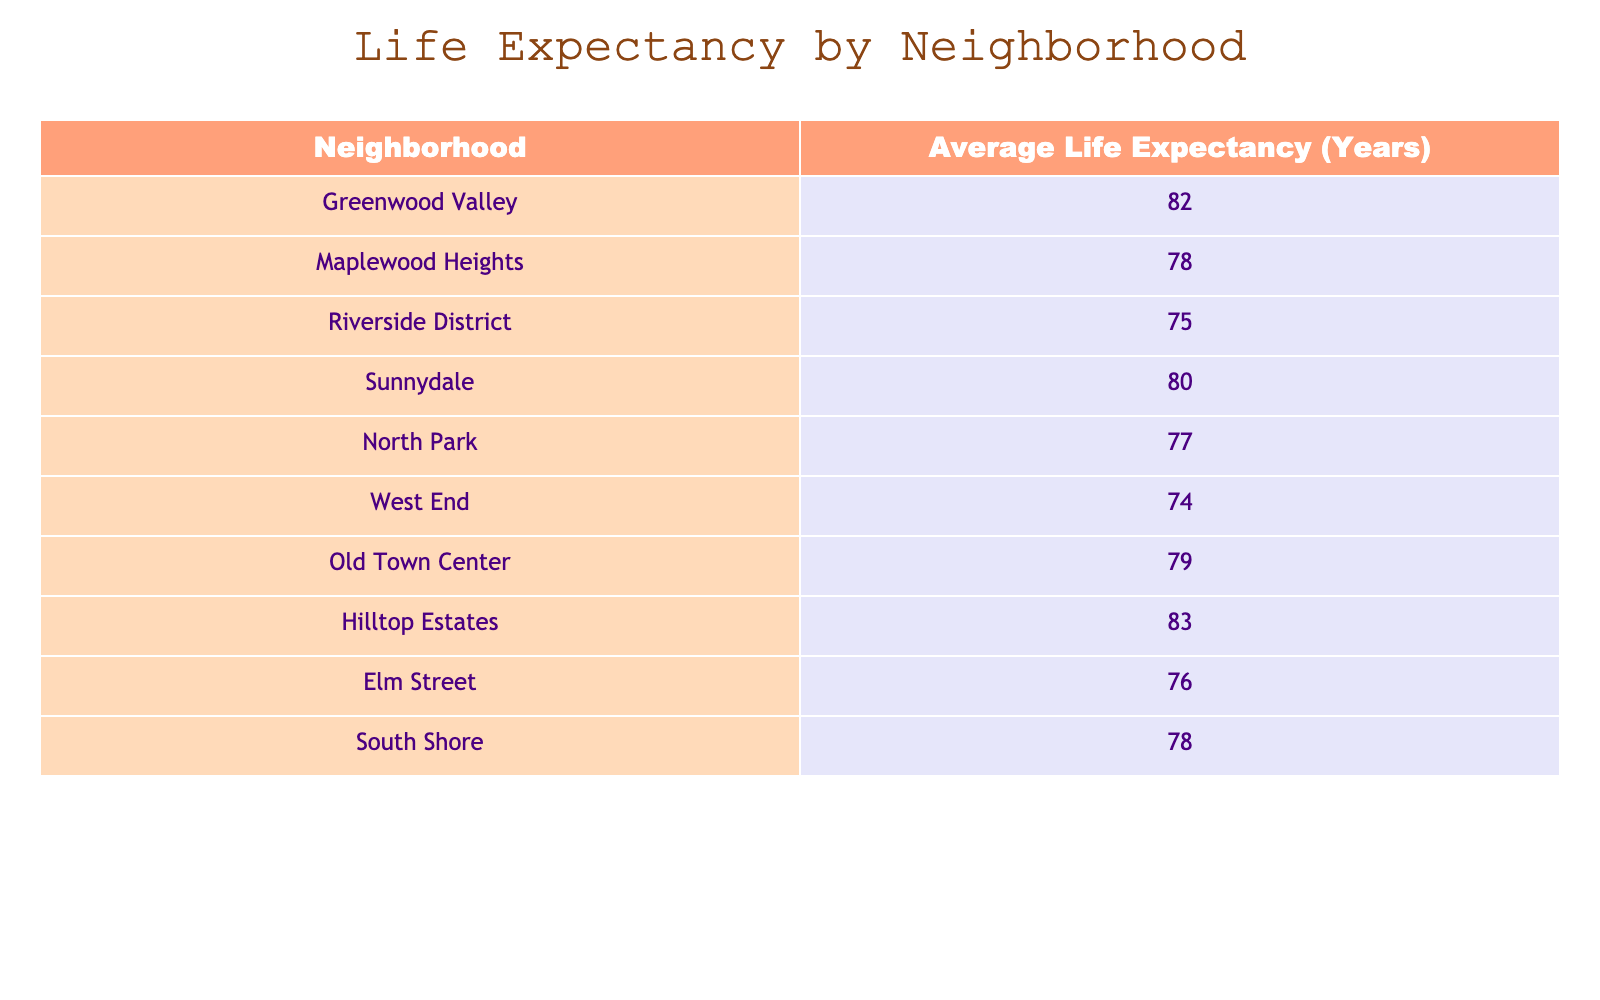What is the average life expectancy in the town? To find the average, we sum the life expectancies of all neighborhoods: (82 + 78 + 75 + 80 + 77 + 74 + 79 + 83 + 76 + 78) = 783. There are 10 neighborhoods, so the average is 783/10 = 78.3
Answer: 78.3 Which neighborhood has the highest life expectancy? From the table, Hilltop Estates has the highest life expectancy of 83 years, which is greater than all other listed neighborhoods.
Answer: Hilltop Estates Is Maplewood Heights' life expectancy greater than that of South Shore? Maplewood Heights' life expectancy is 78 years and South Shore's is also 78 years. Therefore, Maplewood Heights is not greater than South Shore.
Answer: No What is the difference in life expectancy between Greenwood Valley and West End? Greenwood Valley has a life expectancy of 82 years, while West End has 74 years. The difference is calculated as 82 - 74 = 8 years.
Answer: 8 years Which neighborhoods have a life expectancy above 80 years? By examining the table, Greenwood Valley (82 years) and Hilltop Estates (83 years) both have life expectancies above 80 years.
Answer: Greenwood Valley and Hilltop Estates Is the average life expectancy of neighborhoods in the North Park and West End greater than 75 years? North Park has a life expectancy of 77 years, and West End has 74 years. The average of these two is (77 + 74) / 2 = 75.5 years, which is greater than 75 years.
Answer: Yes How many neighborhoods have a life expectancy below 78 years? From the table, the neighborhoods with life expectancy below 78 years are Riverside District (75), West End (74), and Elm Street (76). This totals 3 neighborhoods.
Answer: 3 What is the median life expectancy of the neighborhoods listed? To find the median, we list the life expectancies in order: 74, 75, 76, 77, 78, 78, 79, 80, 82, 83. The median is the average of the 5th and 6th values, which are both 78. Thus, the median is (78 + 78) / 2 = 78.
Answer: 78 Which neighborhood has a life expectancy closest to the overall average? The overall average life expectancy is 78.3 years. The life expectancy values closest to the average are those of Maplewood Heights (78 years) and South Shore (78 years).
Answer: Maplewood Heights and South Shore 